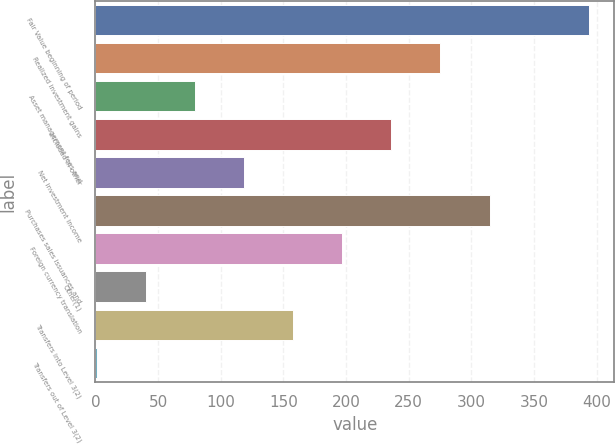Convert chart to OTSL. <chart><loc_0><loc_0><loc_500><loc_500><bar_chart><fcel>Fair Value beginning of period<fcel>Realized investment gains<fcel>Asset management fees and<fcel>Included in other<fcel>Net investment income<fcel>Purchases sales issuances and<fcel>Foreign currency translation<fcel>Other(1)<fcel>Transfers into Level 3(2)<fcel>Transfers out of Level 3(2)<nl><fcel>394.2<fcel>275.4<fcel>79.4<fcel>236.2<fcel>118.6<fcel>314.6<fcel>197<fcel>40.2<fcel>157.8<fcel>1<nl></chart> 